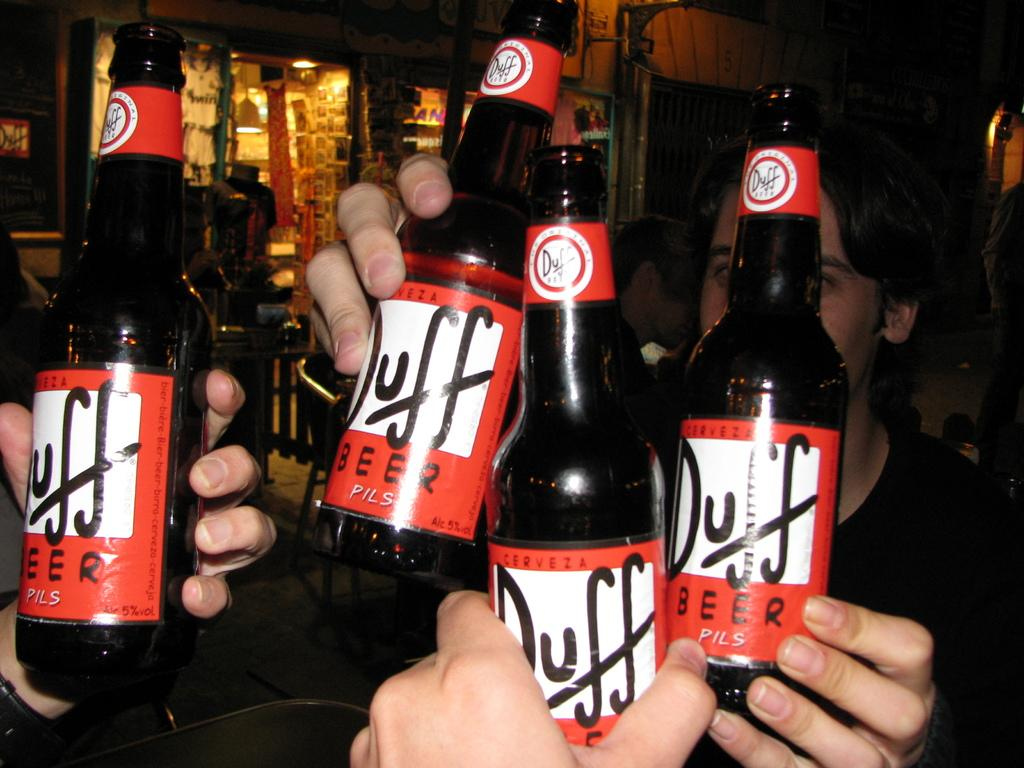<image>
Give a short and clear explanation of the subsequent image. People hold bottles of Duff brand beer together. 